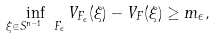<formula> <loc_0><loc_0><loc_500><loc_500>\inf _ { \xi \in S ^ { n - 1 } \ F _ { \epsilon } } V _ { F _ { \epsilon } } ( \xi ) - V _ { F } ( \xi ) \geq m _ { \epsilon } ,</formula> 